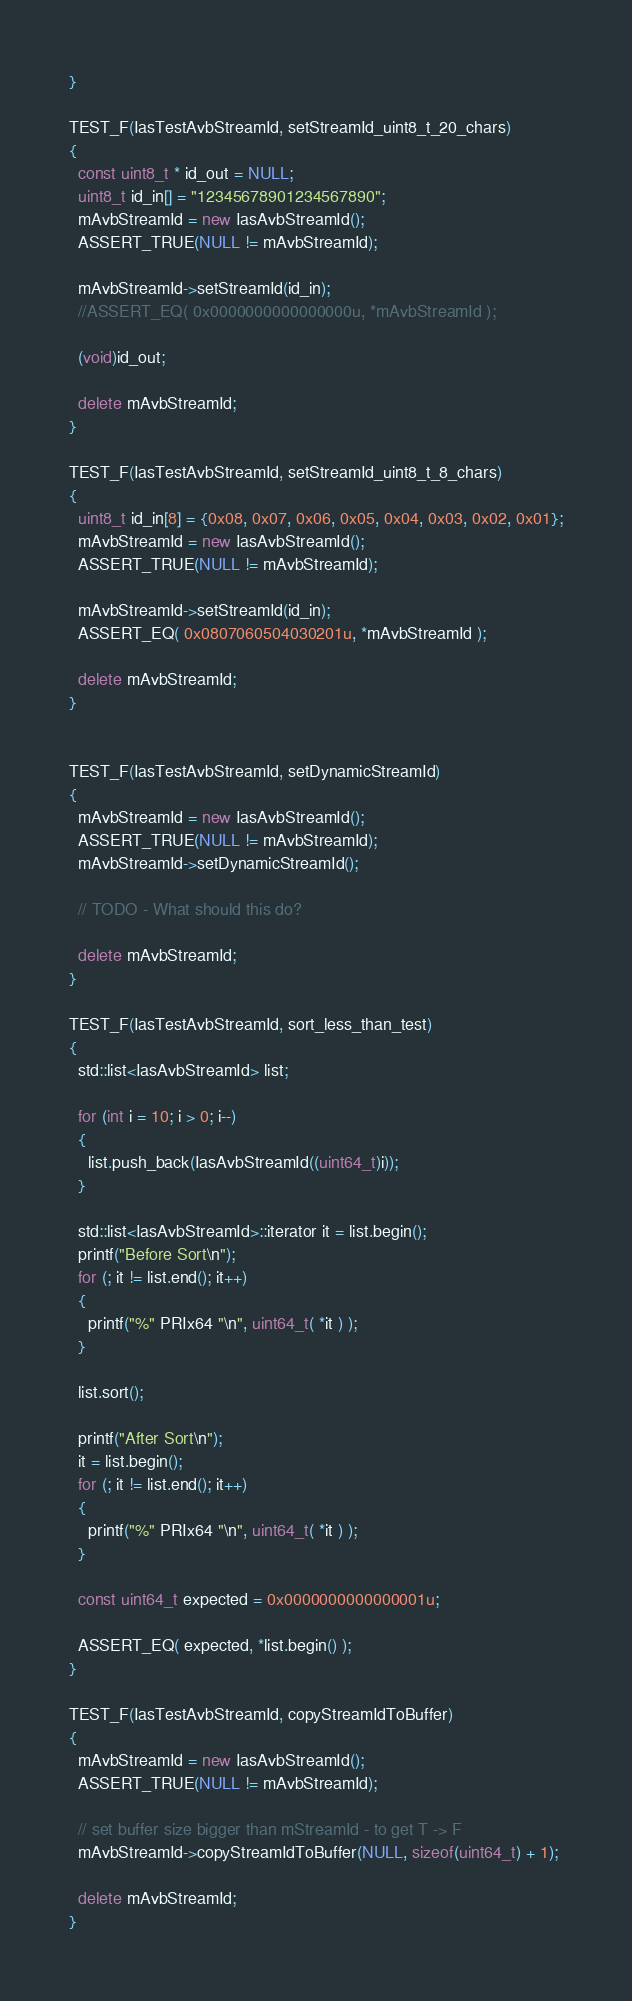Convert code to text. <code><loc_0><loc_0><loc_500><loc_500><_C++_>}

TEST_F(IasTestAvbStreamId, setStreamId_uint8_t_20_chars)
{
  const uint8_t * id_out = NULL;
  uint8_t id_in[] = "12345678901234567890";
  mAvbStreamId = new IasAvbStreamId();
  ASSERT_TRUE(NULL != mAvbStreamId);

  mAvbStreamId->setStreamId(id_in);
  //ASSERT_EQ( 0x0000000000000000u, *mAvbStreamId );

  (void)id_out;

  delete mAvbStreamId;
}

TEST_F(IasTestAvbStreamId, setStreamId_uint8_t_8_chars)
{
  uint8_t id_in[8] = {0x08, 0x07, 0x06, 0x05, 0x04, 0x03, 0x02, 0x01};
  mAvbStreamId = new IasAvbStreamId();
  ASSERT_TRUE(NULL != mAvbStreamId);

  mAvbStreamId->setStreamId(id_in);
  ASSERT_EQ( 0x0807060504030201u, *mAvbStreamId );

  delete mAvbStreamId;
}


TEST_F(IasTestAvbStreamId, setDynamicStreamId)
{
  mAvbStreamId = new IasAvbStreamId();
  ASSERT_TRUE(NULL != mAvbStreamId);
  mAvbStreamId->setDynamicStreamId();

  // TODO - What should this do?

  delete mAvbStreamId;
}

TEST_F(IasTestAvbStreamId, sort_less_than_test)
{
  std::list<IasAvbStreamId> list;

  for (int i = 10; i > 0; i--)
  {
    list.push_back(IasAvbStreamId((uint64_t)i));
  }

  std::list<IasAvbStreamId>::iterator it = list.begin();
  printf("Before Sort\n");
  for (; it != list.end(); it++)
  {
    printf("%" PRIx64 "\n", uint64_t( *it ) );
  }

  list.sort();

  printf("After Sort\n");
  it = list.begin();
  for (; it != list.end(); it++)
  {
    printf("%" PRIx64 "\n", uint64_t( *it ) );
  }

  const uint64_t expected = 0x0000000000000001u;

  ASSERT_EQ( expected, *list.begin() );
}

TEST_F(IasTestAvbStreamId, copyStreamIdToBuffer)
{
  mAvbStreamId = new IasAvbStreamId();
  ASSERT_TRUE(NULL != mAvbStreamId);

  // set buffer size bigger than mStreamId - to get T -> F
  mAvbStreamId->copyStreamIdToBuffer(NULL, sizeof(uint64_t) + 1);

  delete mAvbStreamId;
}
</code> 